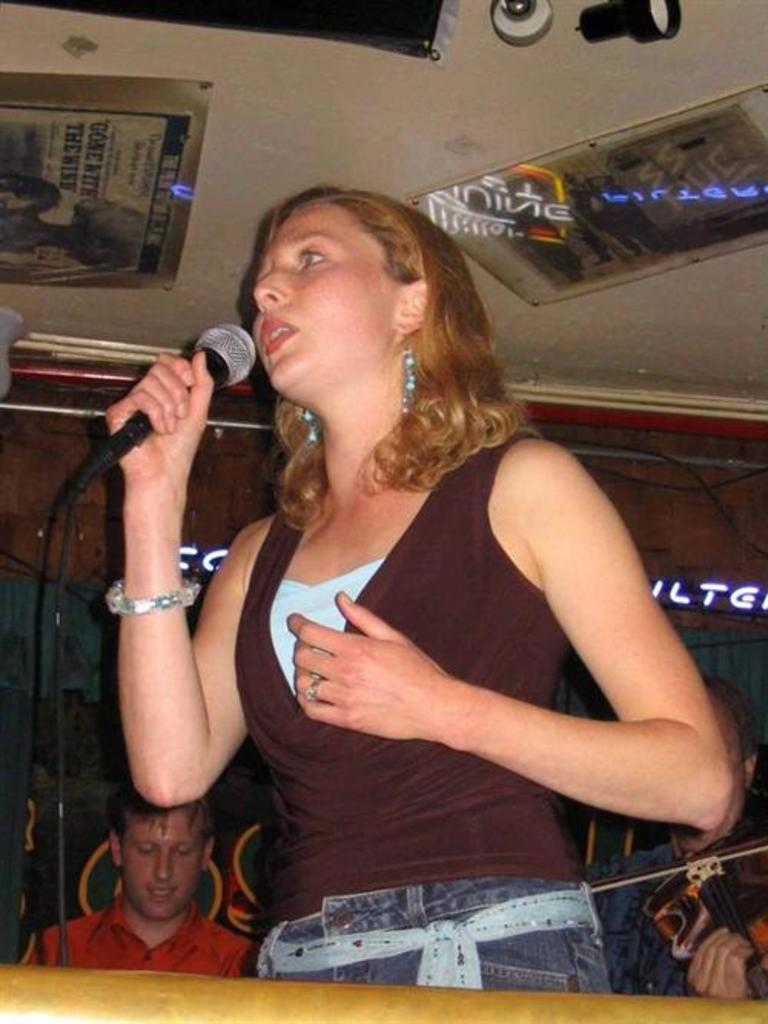What is the woman in the image doing? The woman is speaking with the help of a microphone. Can you describe the man's position in the image? The man is seated in the image. What language is the woman speaking in the image? The provided facts do not mention the language the woman is speaking, so it cannot be determined from the image. What type of beam is supporting the man's position in the image? There is no beam present in the image; the man is seated on a surface. 